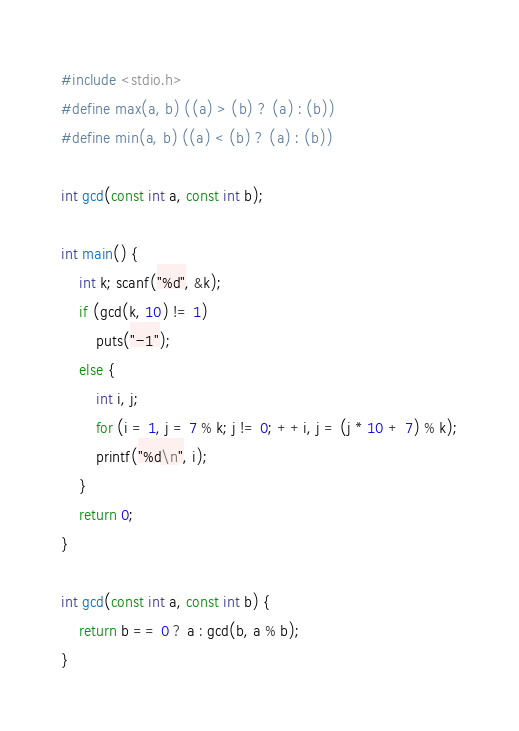Convert code to text. <code><loc_0><loc_0><loc_500><loc_500><_C_>#include <stdio.h>
#define max(a, b) ((a) > (b) ? (a) : (b))
#define min(a, b) ((a) < (b) ? (a) : (b))

int gcd(const int a, const int b);

int main() {
	int k; scanf("%d", &k);
	if (gcd(k, 10) != 1)
		puts("-1");
	else {
		int i, j;
		for (i = 1, j = 7 % k; j != 0; ++i, j = (j * 10 + 7) % k);
		printf("%d\n", i);
	}
	return 0;
}

int gcd(const int a, const int b) {
	return b == 0 ? a : gcd(b, a % b);
}

</code> 